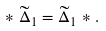<formula> <loc_0><loc_0><loc_500><loc_500>* \widetilde { \Delta } _ { 1 } = \widetilde { \Delta } _ { 1 } * .</formula> 